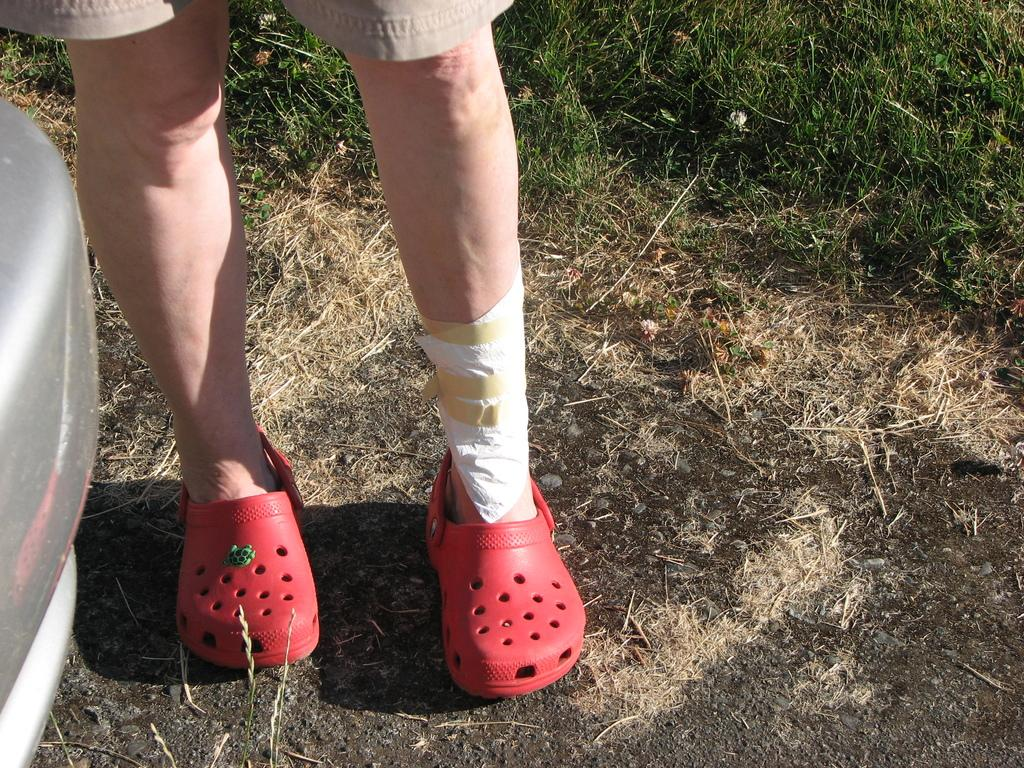What body parts are visible in the image? Human legs are visible in the image. What type of clothing is the person wearing? The person is wearing shorts and shoes. What type of terrain is visible in the image? Dry grass is present in the image. Can you describe the vegetation in the image? Grass is visible in the image. What is located on the left side of the image? There is an object on the left side of the image. What rate is the straw being consumed by the fowl in the image? There is no straw or fowl present in the image; it features human legs, clothing, and an object on the left side. 